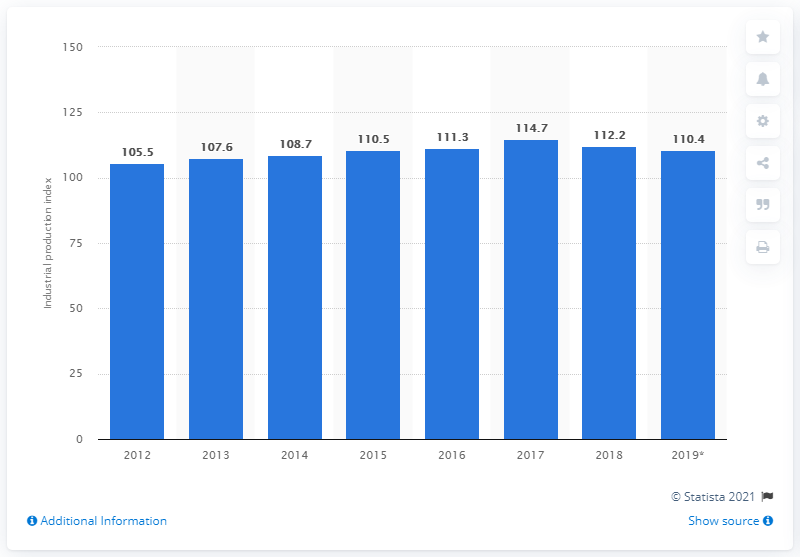Indicate a few pertinent items in this graphic. The industrial production index in Vietnam in 2019 was 110.4, indicating a strong level of industrial output in the country that year. 